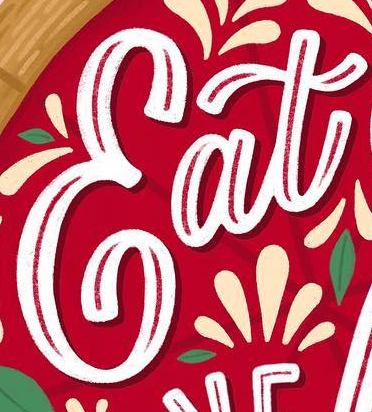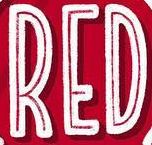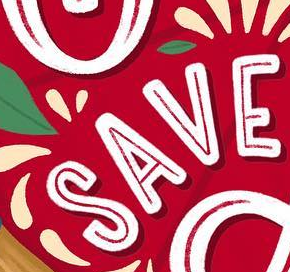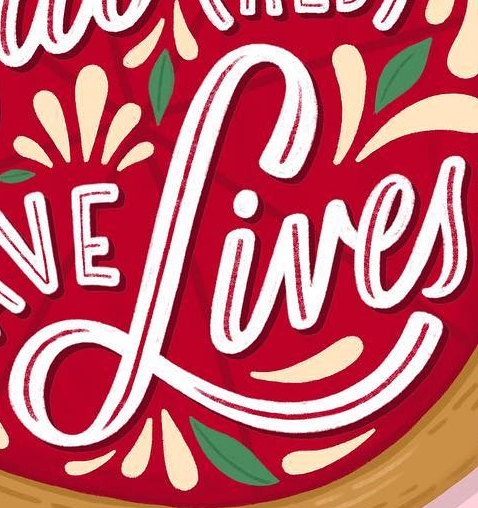What text appears in these images from left to right, separated by a semicolon? Eat; RED; SAVE; Lives 